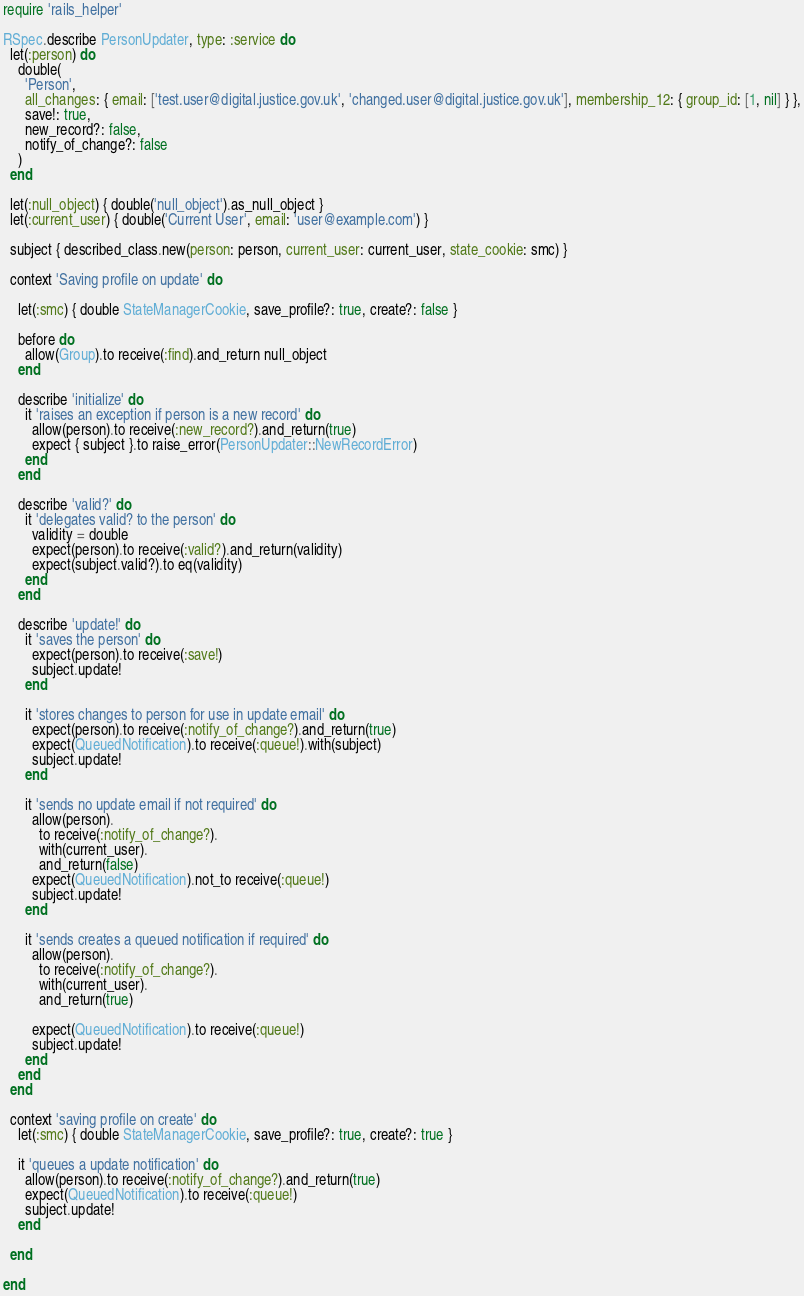<code> <loc_0><loc_0><loc_500><loc_500><_Ruby_>require 'rails_helper'

RSpec.describe PersonUpdater, type: :service do
  let(:person) do
    double(
      'Person',
      all_changes: { email: ['test.user@digital.justice.gov.uk', 'changed.user@digital.justice.gov.uk'], membership_12: { group_id: [1, nil] } },
      save!: true,
      new_record?: false,
      notify_of_change?: false
    )
  end

  let(:null_object) { double('null_object').as_null_object }
  let(:current_user) { double('Current User', email: 'user@example.com') }

  subject { described_class.new(person: person, current_user: current_user, state_cookie: smc) }

  context 'Saving profile on update' do

    let(:smc) { double StateManagerCookie, save_profile?: true, create?: false }

    before do
      allow(Group).to receive(:find).and_return null_object
    end

    describe 'initialize' do
      it 'raises an exception if person is a new record' do
        allow(person).to receive(:new_record?).and_return(true)
        expect { subject }.to raise_error(PersonUpdater::NewRecordError)
      end
    end

    describe 'valid?' do
      it 'delegates valid? to the person' do
        validity = double
        expect(person).to receive(:valid?).and_return(validity)
        expect(subject.valid?).to eq(validity)
      end
    end

    describe 'update!' do
      it 'saves the person' do
        expect(person).to receive(:save!)
        subject.update!
      end

      it 'stores changes to person for use in update email' do
        expect(person).to receive(:notify_of_change?).and_return(true)
        expect(QueuedNotification).to receive(:queue!).with(subject)
        subject.update!
      end

      it 'sends no update email if not required' do
        allow(person).
          to receive(:notify_of_change?).
          with(current_user).
          and_return(false)
        expect(QueuedNotification).not_to receive(:queue!)
        subject.update!
      end

      it 'sends creates a queued notification if required' do
        allow(person).
          to receive(:notify_of_change?).
          with(current_user).
          and_return(true)

        expect(QueuedNotification).to receive(:queue!)
        subject.update!
      end
    end
  end

  context 'saving profile on create' do
    let(:smc) { double StateManagerCookie, save_profile?: true, create?: true }

    it 'queues a update notification' do
      allow(person).to receive(:notify_of_change?).and_return(true)
      expect(QueuedNotification).to receive(:queue!)
      subject.update!
    end

  end

end
</code> 